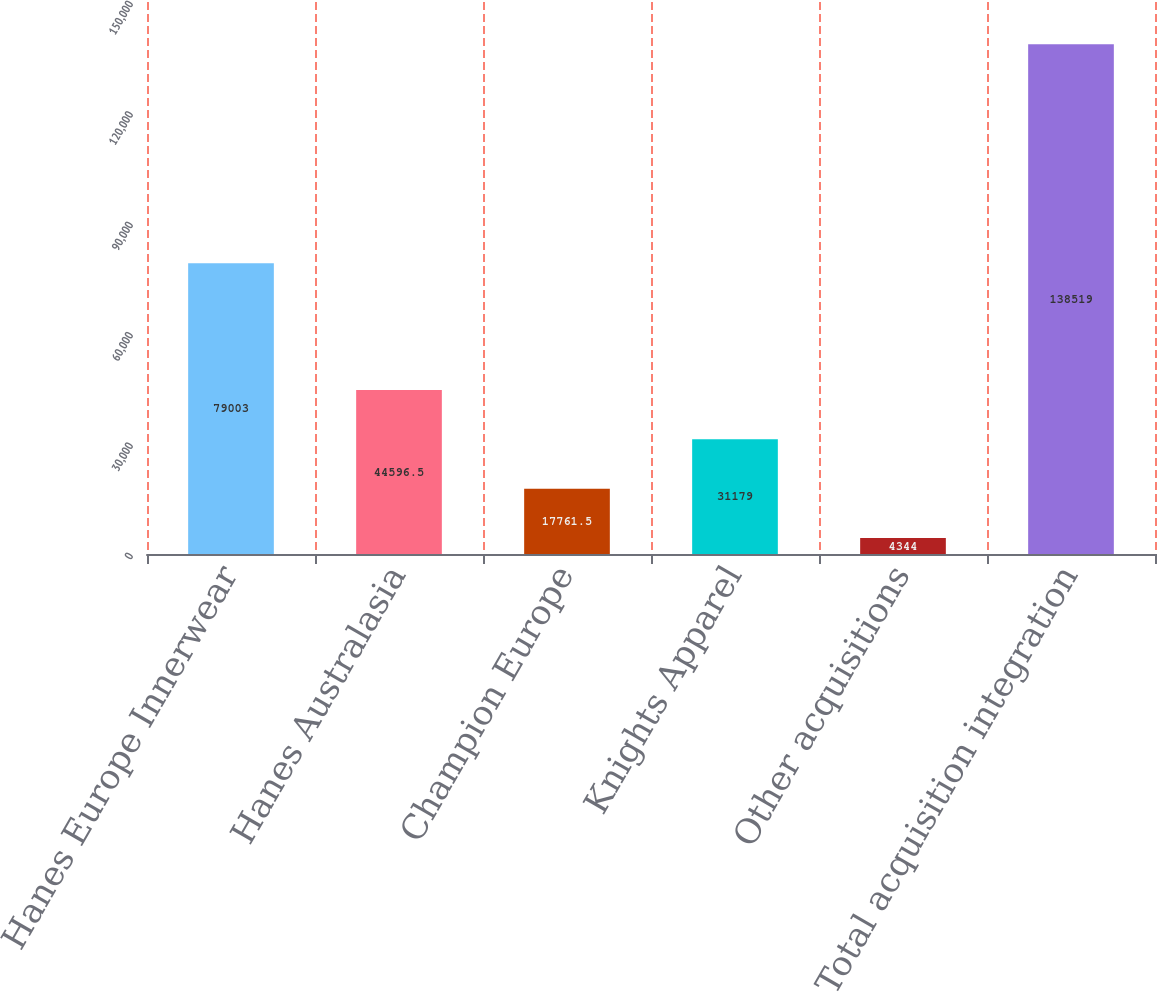Convert chart. <chart><loc_0><loc_0><loc_500><loc_500><bar_chart><fcel>Hanes Europe Innerwear<fcel>Hanes Australasia<fcel>Champion Europe<fcel>Knights Apparel<fcel>Other acquisitions<fcel>Total acquisition integration<nl><fcel>79003<fcel>44596.5<fcel>17761.5<fcel>31179<fcel>4344<fcel>138519<nl></chart> 